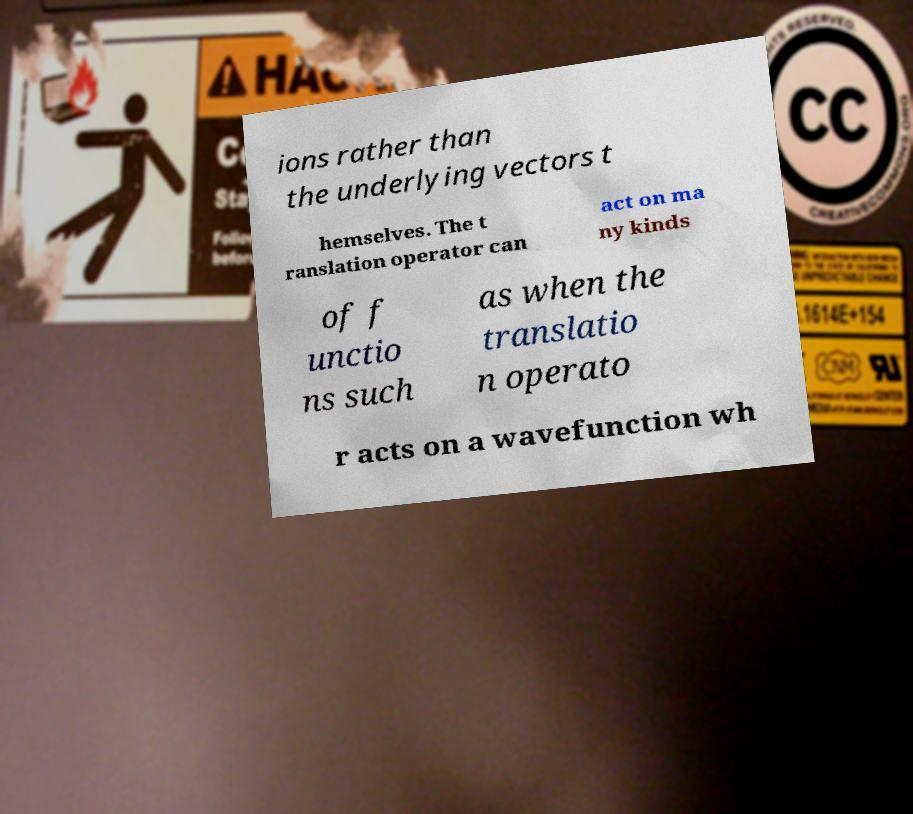Can you read and provide the text displayed in the image?This photo seems to have some interesting text. Can you extract and type it out for me? ions rather than the underlying vectors t hemselves. The t ranslation operator can act on ma ny kinds of f unctio ns such as when the translatio n operato r acts on a wavefunction wh 